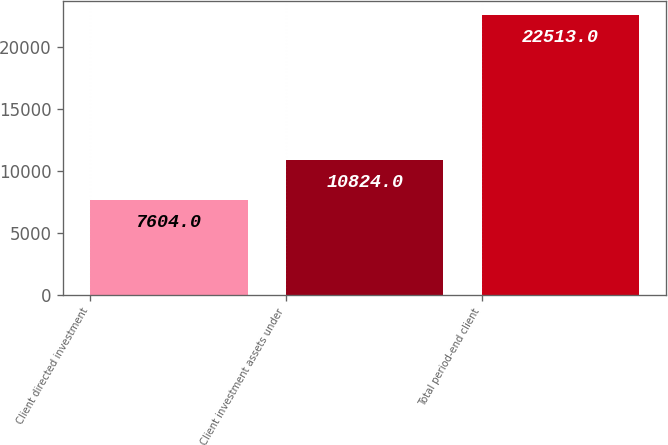<chart> <loc_0><loc_0><loc_500><loc_500><bar_chart><fcel>Client directed investment<fcel>Client investment assets under<fcel>Total period-end client<nl><fcel>7604<fcel>10824<fcel>22513<nl></chart> 